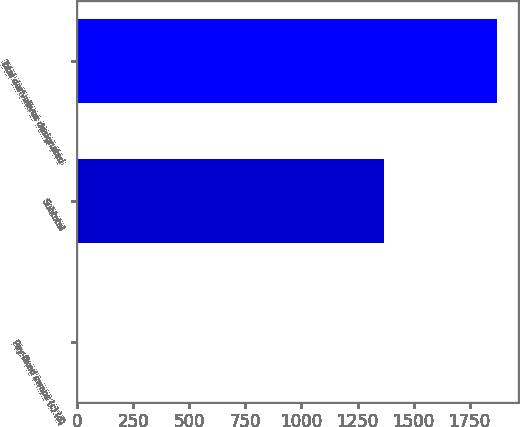<chart> <loc_0><loc_0><loc_500><loc_500><bar_chart><fcel>Pay-fixed swaps (c) (d)<fcel>Subtotal<fcel>Total derivatives designated<nl><fcel>2<fcel>1367<fcel>1872<nl></chart> 